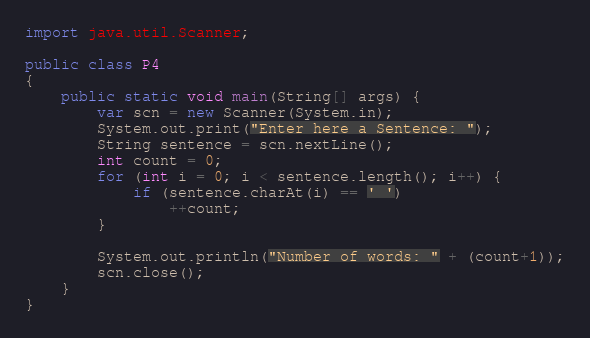<code> <loc_0><loc_0><loc_500><loc_500><_Java_>import java.util.Scanner;

public class P4
{
    public static void main(String[] args) {
        var scn = new Scanner(System.in);
        System.out.print("Enter here a Sentence: ");
        String sentence = scn.nextLine();
        int count = 0;
        for (int i = 0; i < sentence.length(); i++) {
            if (sentence.charAt(i) == ' ')
                ++count;
        }

        System.out.println("Number of words: " + (count+1));
        scn.close();
    }
}</code> 